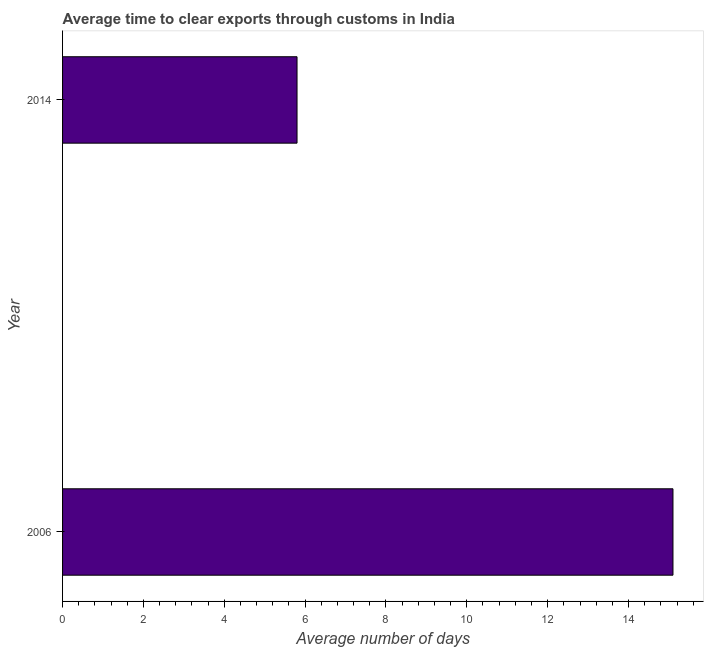Does the graph contain any zero values?
Keep it short and to the point. No. Does the graph contain grids?
Offer a very short reply. No. What is the title of the graph?
Provide a short and direct response. Average time to clear exports through customs in India. What is the label or title of the X-axis?
Ensure brevity in your answer.  Average number of days. What is the time to clear exports through customs in 2006?
Provide a succinct answer. 15.1. Across all years, what is the maximum time to clear exports through customs?
Your response must be concise. 15.1. In which year was the time to clear exports through customs minimum?
Offer a very short reply. 2014. What is the sum of the time to clear exports through customs?
Offer a very short reply. 20.9. What is the average time to clear exports through customs per year?
Keep it short and to the point. 10.45. What is the median time to clear exports through customs?
Your response must be concise. 10.45. What is the ratio of the time to clear exports through customs in 2006 to that in 2014?
Your answer should be compact. 2.6. How many years are there in the graph?
Ensure brevity in your answer.  2. What is the difference between two consecutive major ticks on the X-axis?
Make the answer very short. 2. Are the values on the major ticks of X-axis written in scientific E-notation?
Your answer should be very brief. No. What is the Average number of days in 2006?
Keep it short and to the point. 15.1. What is the ratio of the Average number of days in 2006 to that in 2014?
Offer a very short reply. 2.6. 